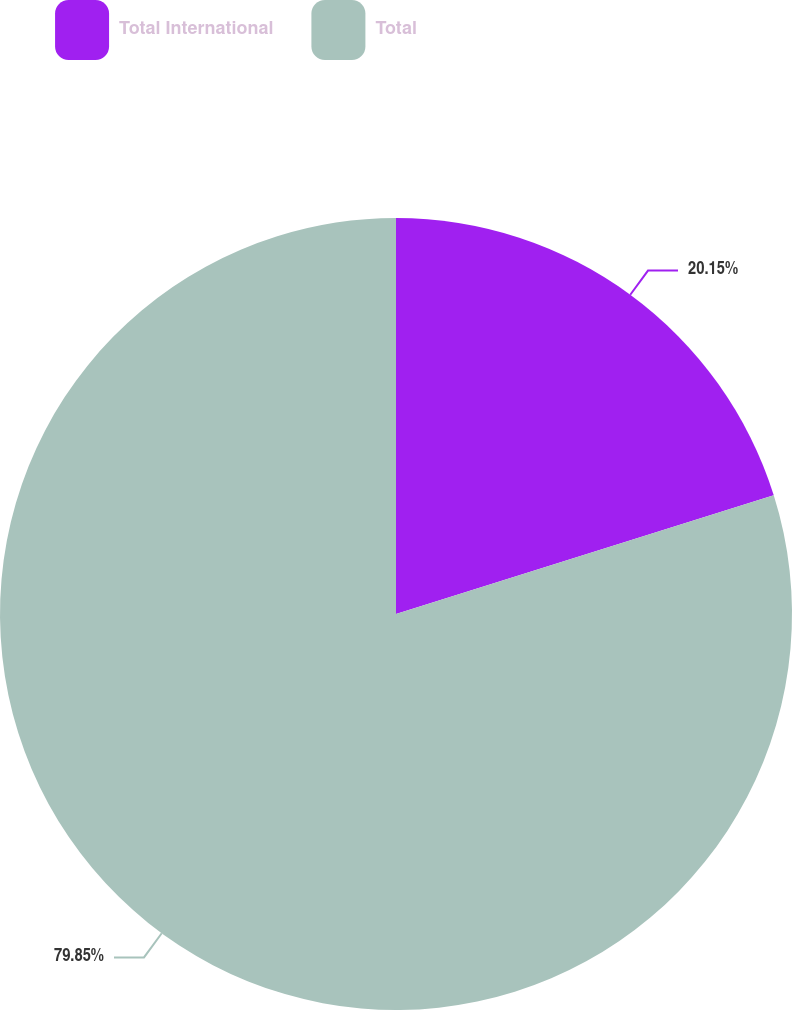Convert chart. <chart><loc_0><loc_0><loc_500><loc_500><pie_chart><fcel>Total International<fcel>Total<nl><fcel>20.15%<fcel>79.85%<nl></chart> 